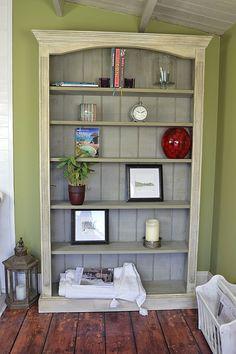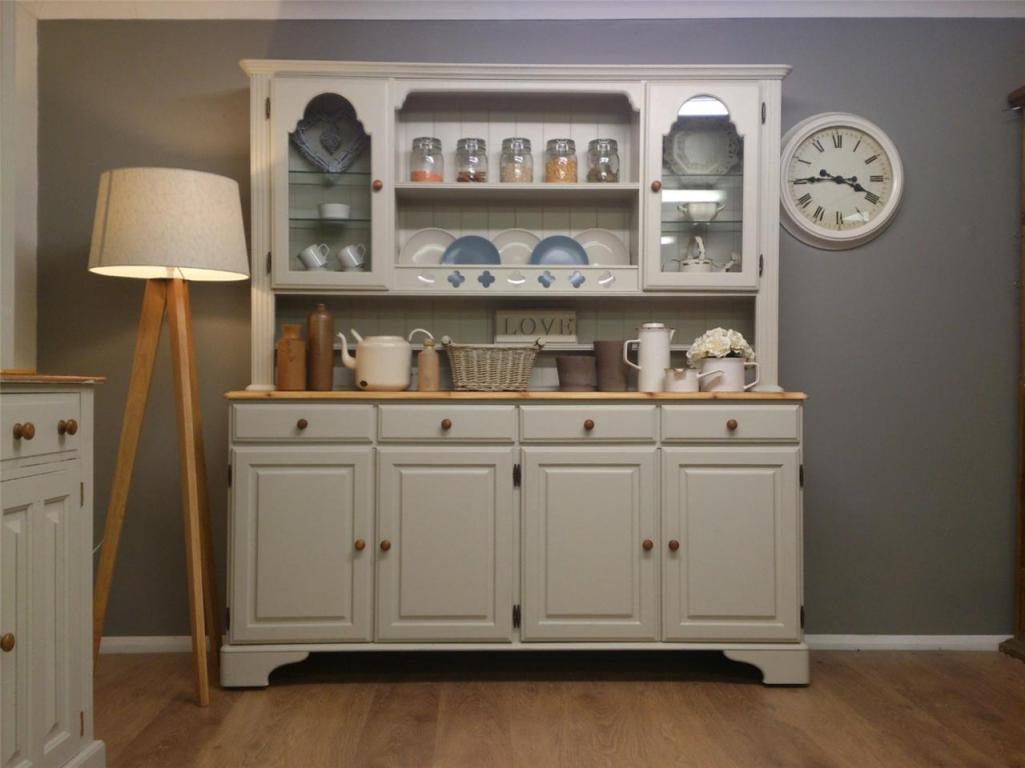The first image is the image on the left, the second image is the image on the right. Assess this claim about the two images: "In one image a bookshelf with four levels has a decorative inner arc framing the upper shelf on which a clock is sitting.". Correct or not? Answer yes or no. No. The first image is the image on the left, the second image is the image on the right. Analyze the images presented: Is the assertion "there is a bookshelf on a wood floor and a vase of flowers on top" valid? Answer yes or no. No. 